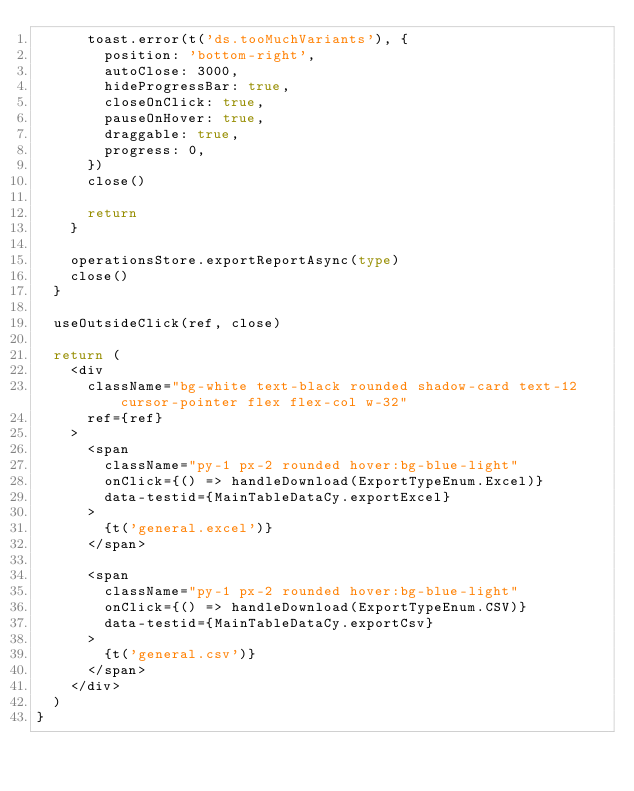<code> <loc_0><loc_0><loc_500><loc_500><_TypeScript_>      toast.error(t('ds.tooMuchVariants'), {
        position: 'bottom-right',
        autoClose: 3000,
        hideProgressBar: true,
        closeOnClick: true,
        pauseOnHover: true,
        draggable: true,
        progress: 0,
      })
      close()

      return
    }

    operationsStore.exportReportAsync(type)
    close()
  }

  useOutsideClick(ref, close)

  return (
    <div
      className="bg-white text-black rounded shadow-card text-12 cursor-pointer flex flex-col w-32"
      ref={ref}
    >
      <span
        className="py-1 px-2 rounded hover:bg-blue-light"
        onClick={() => handleDownload(ExportTypeEnum.Excel)}
        data-testid={MainTableDataCy.exportExcel}
      >
        {t('general.excel')}
      </span>

      <span
        className="py-1 px-2 rounded hover:bg-blue-light"
        onClick={() => handleDownload(ExportTypeEnum.CSV)}
        data-testid={MainTableDataCy.exportCsv}
      >
        {t('general.csv')}
      </span>
    </div>
  )
}
</code> 